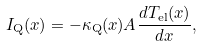Convert formula to latex. <formula><loc_0><loc_0><loc_500><loc_500>I _ { \text {Q} } ( x ) = - \kappa _ { \text {Q} } ( x ) A \frac { d T _ { \text {el} } ( x ) } { d x } ,</formula> 